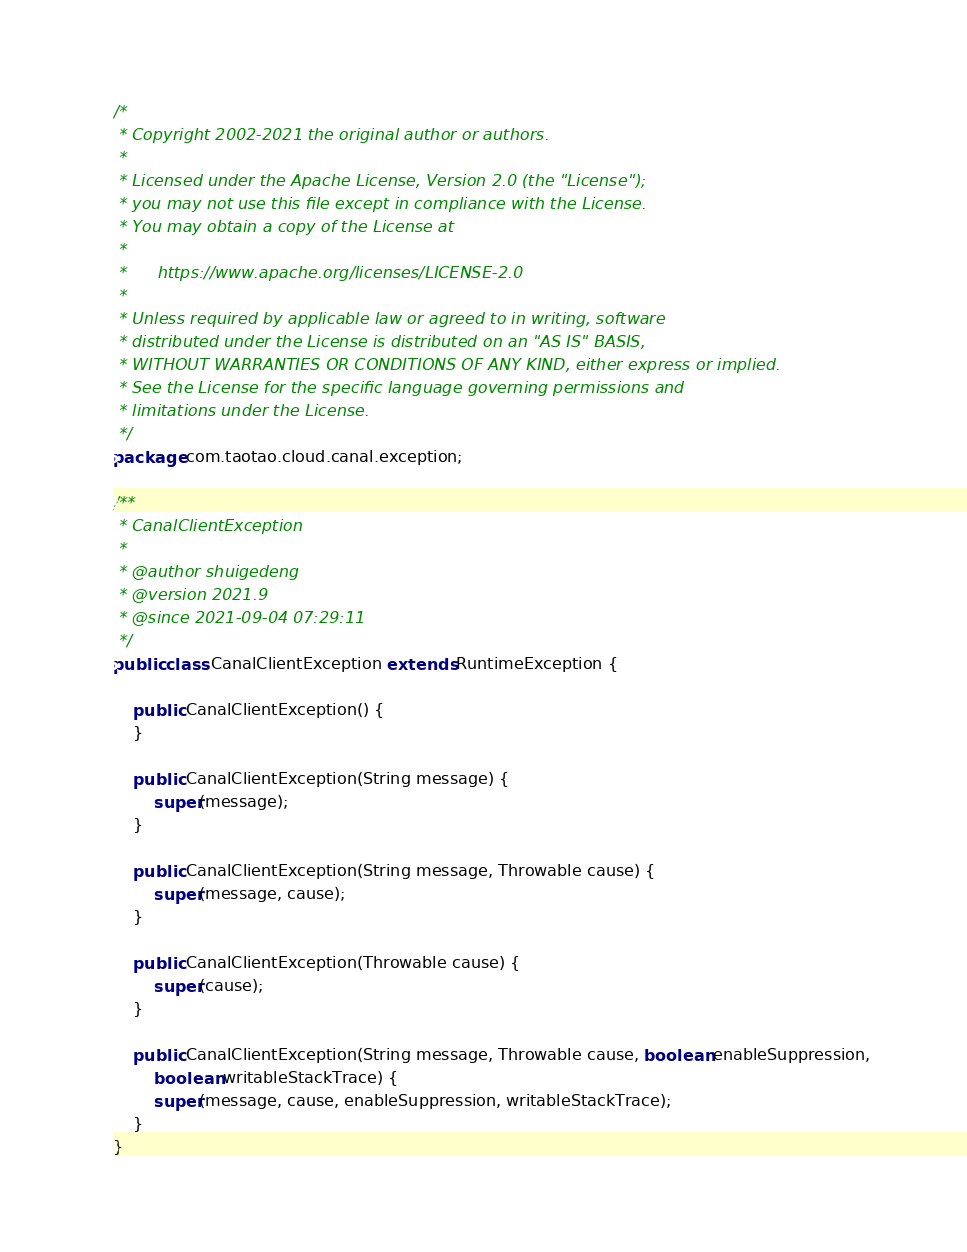Convert code to text. <code><loc_0><loc_0><loc_500><loc_500><_Java_>/*
 * Copyright 2002-2021 the original author or authors.
 *
 * Licensed under the Apache License, Version 2.0 (the "License");
 * you may not use this file except in compliance with the License.
 * You may obtain a copy of the License at
 *
 *      https://www.apache.org/licenses/LICENSE-2.0
 *
 * Unless required by applicable law or agreed to in writing, software
 * distributed under the License is distributed on an "AS IS" BASIS,
 * WITHOUT WARRANTIES OR CONDITIONS OF ANY KIND, either express or implied.
 * See the License for the specific language governing permissions and
 * limitations under the License.
 */
package com.taotao.cloud.canal.exception;

/**
 * CanalClientException 
 *
 * @author shuigedeng
 * @version 2021.9
 * @since 2021-09-04 07:29:11
 */
public class CanalClientException extends RuntimeException {

	public CanalClientException() {
	}

	public CanalClientException(String message) {
		super(message);
	}

	public CanalClientException(String message, Throwable cause) {
		super(message, cause);
	}

	public CanalClientException(Throwable cause) {
		super(cause);
	}

	public CanalClientException(String message, Throwable cause, boolean enableSuppression,
		boolean writableStackTrace) {
		super(message, cause, enableSuppression, writableStackTrace);
	}
}
</code> 